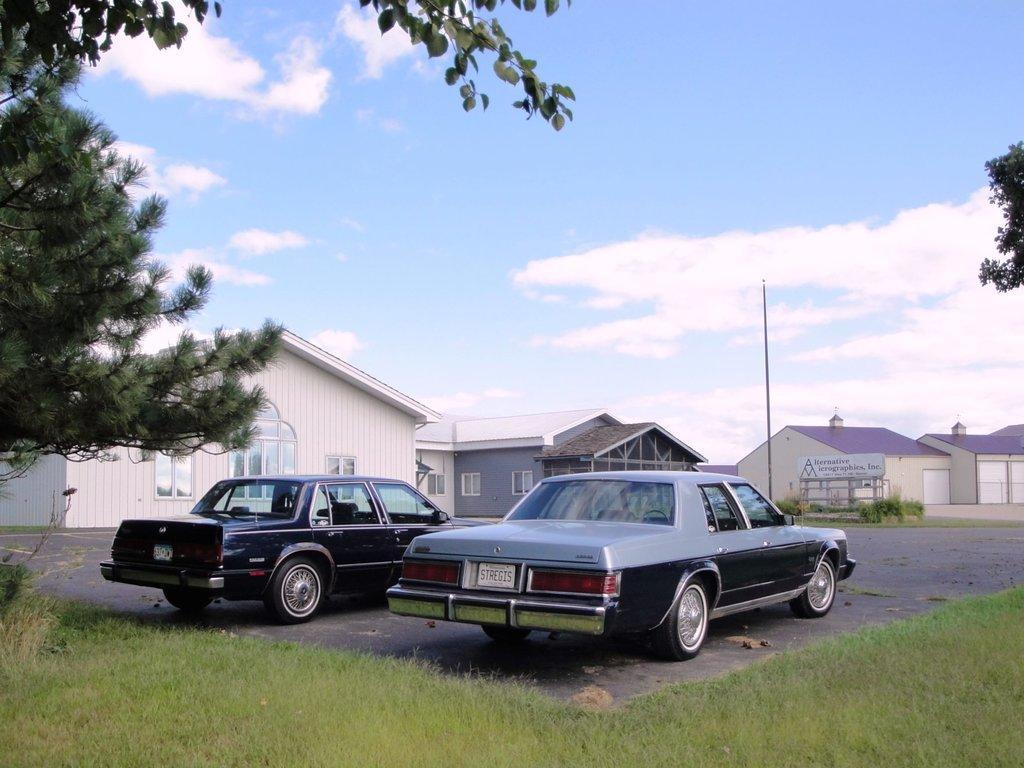Can you describe this image briefly? In this image I can see two cars on the ground. In the background I can see houses, a pole, grass, a board on which something written on it and the sky. On the left side I can see a tree. 